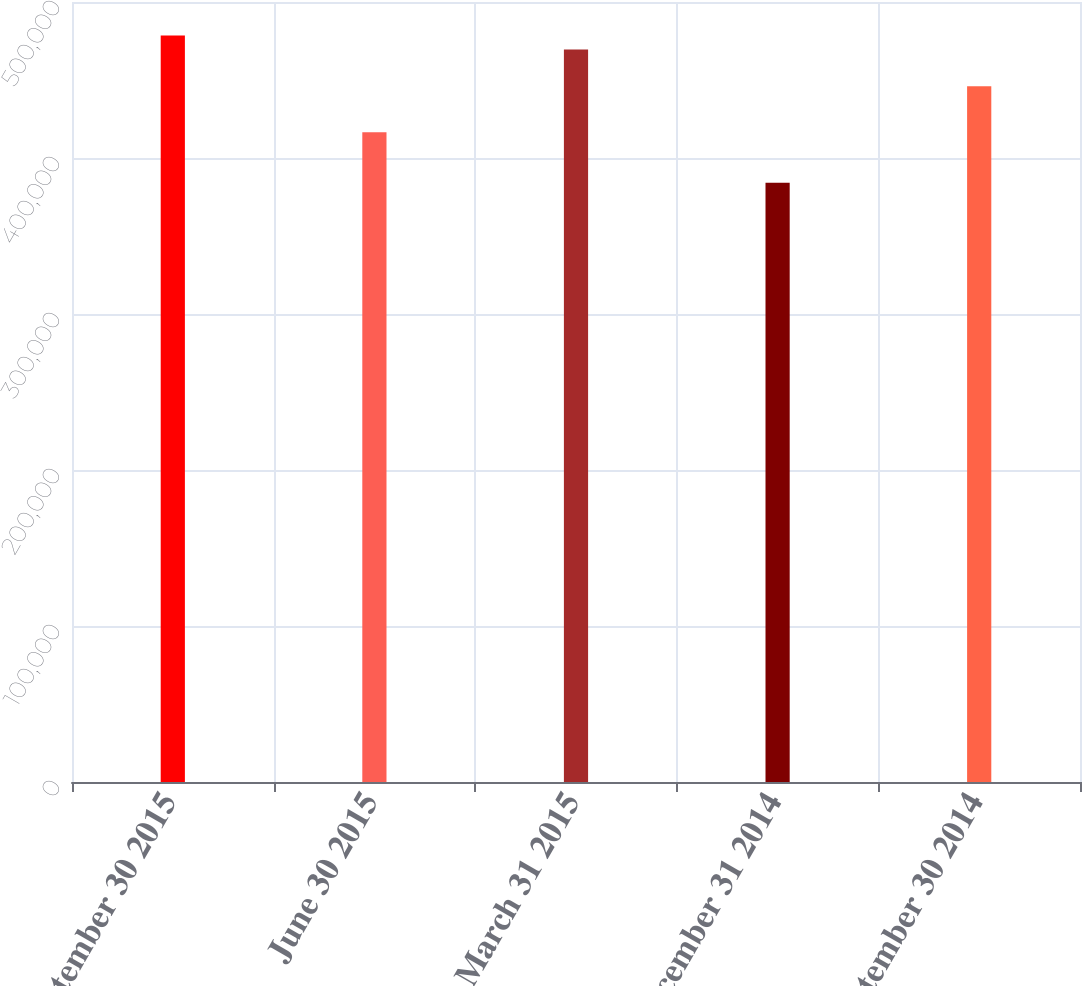Convert chart to OTSL. <chart><loc_0><loc_0><loc_500><loc_500><bar_chart><fcel>September 30 2015<fcel>June 30 2015<fcel>March 31 2015<fcel>December 31 2014<fcel>September 30 2014<nl><fcel>478504<fcel>416516<fcel>469503<fcel>384129<fcel>446016<nl></chart> 